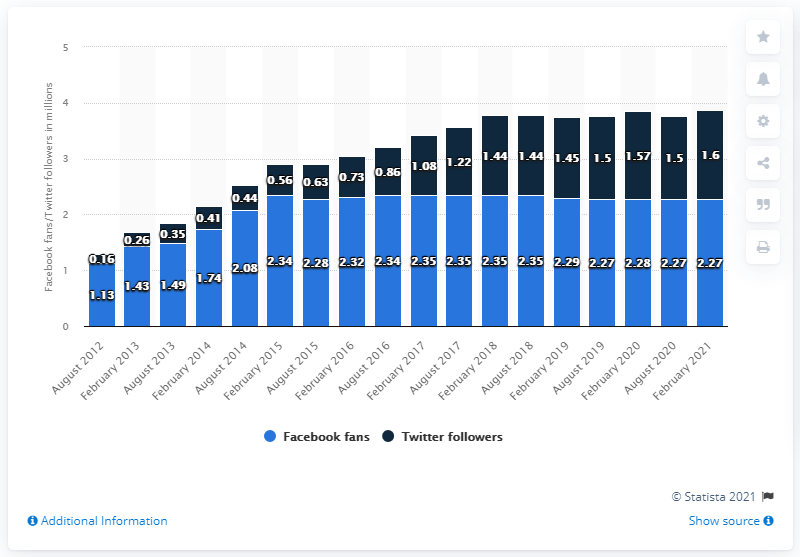Mention a couple of crucial points in this snapshot. As of February 2021, the Baltimore Ravens football team had approximately 2.27 million Facebook followers. 